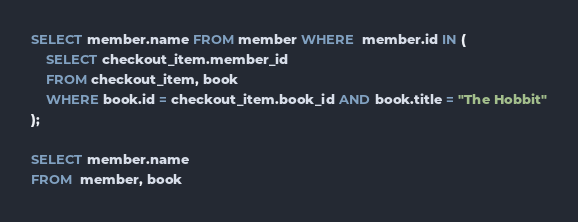<code> <loc_0><loc_0><loc_500><loc_500><_SQL_>SELECT member.name FROM member WHERE  member.id IN (
    SELECT checkout_item.member_id
    FROM checkout_item, book
    WHERE book.id = checkout_item.book_id AND book.title = "The Hobbit"
);

SELECT member.name
FROM  member, book</code> 